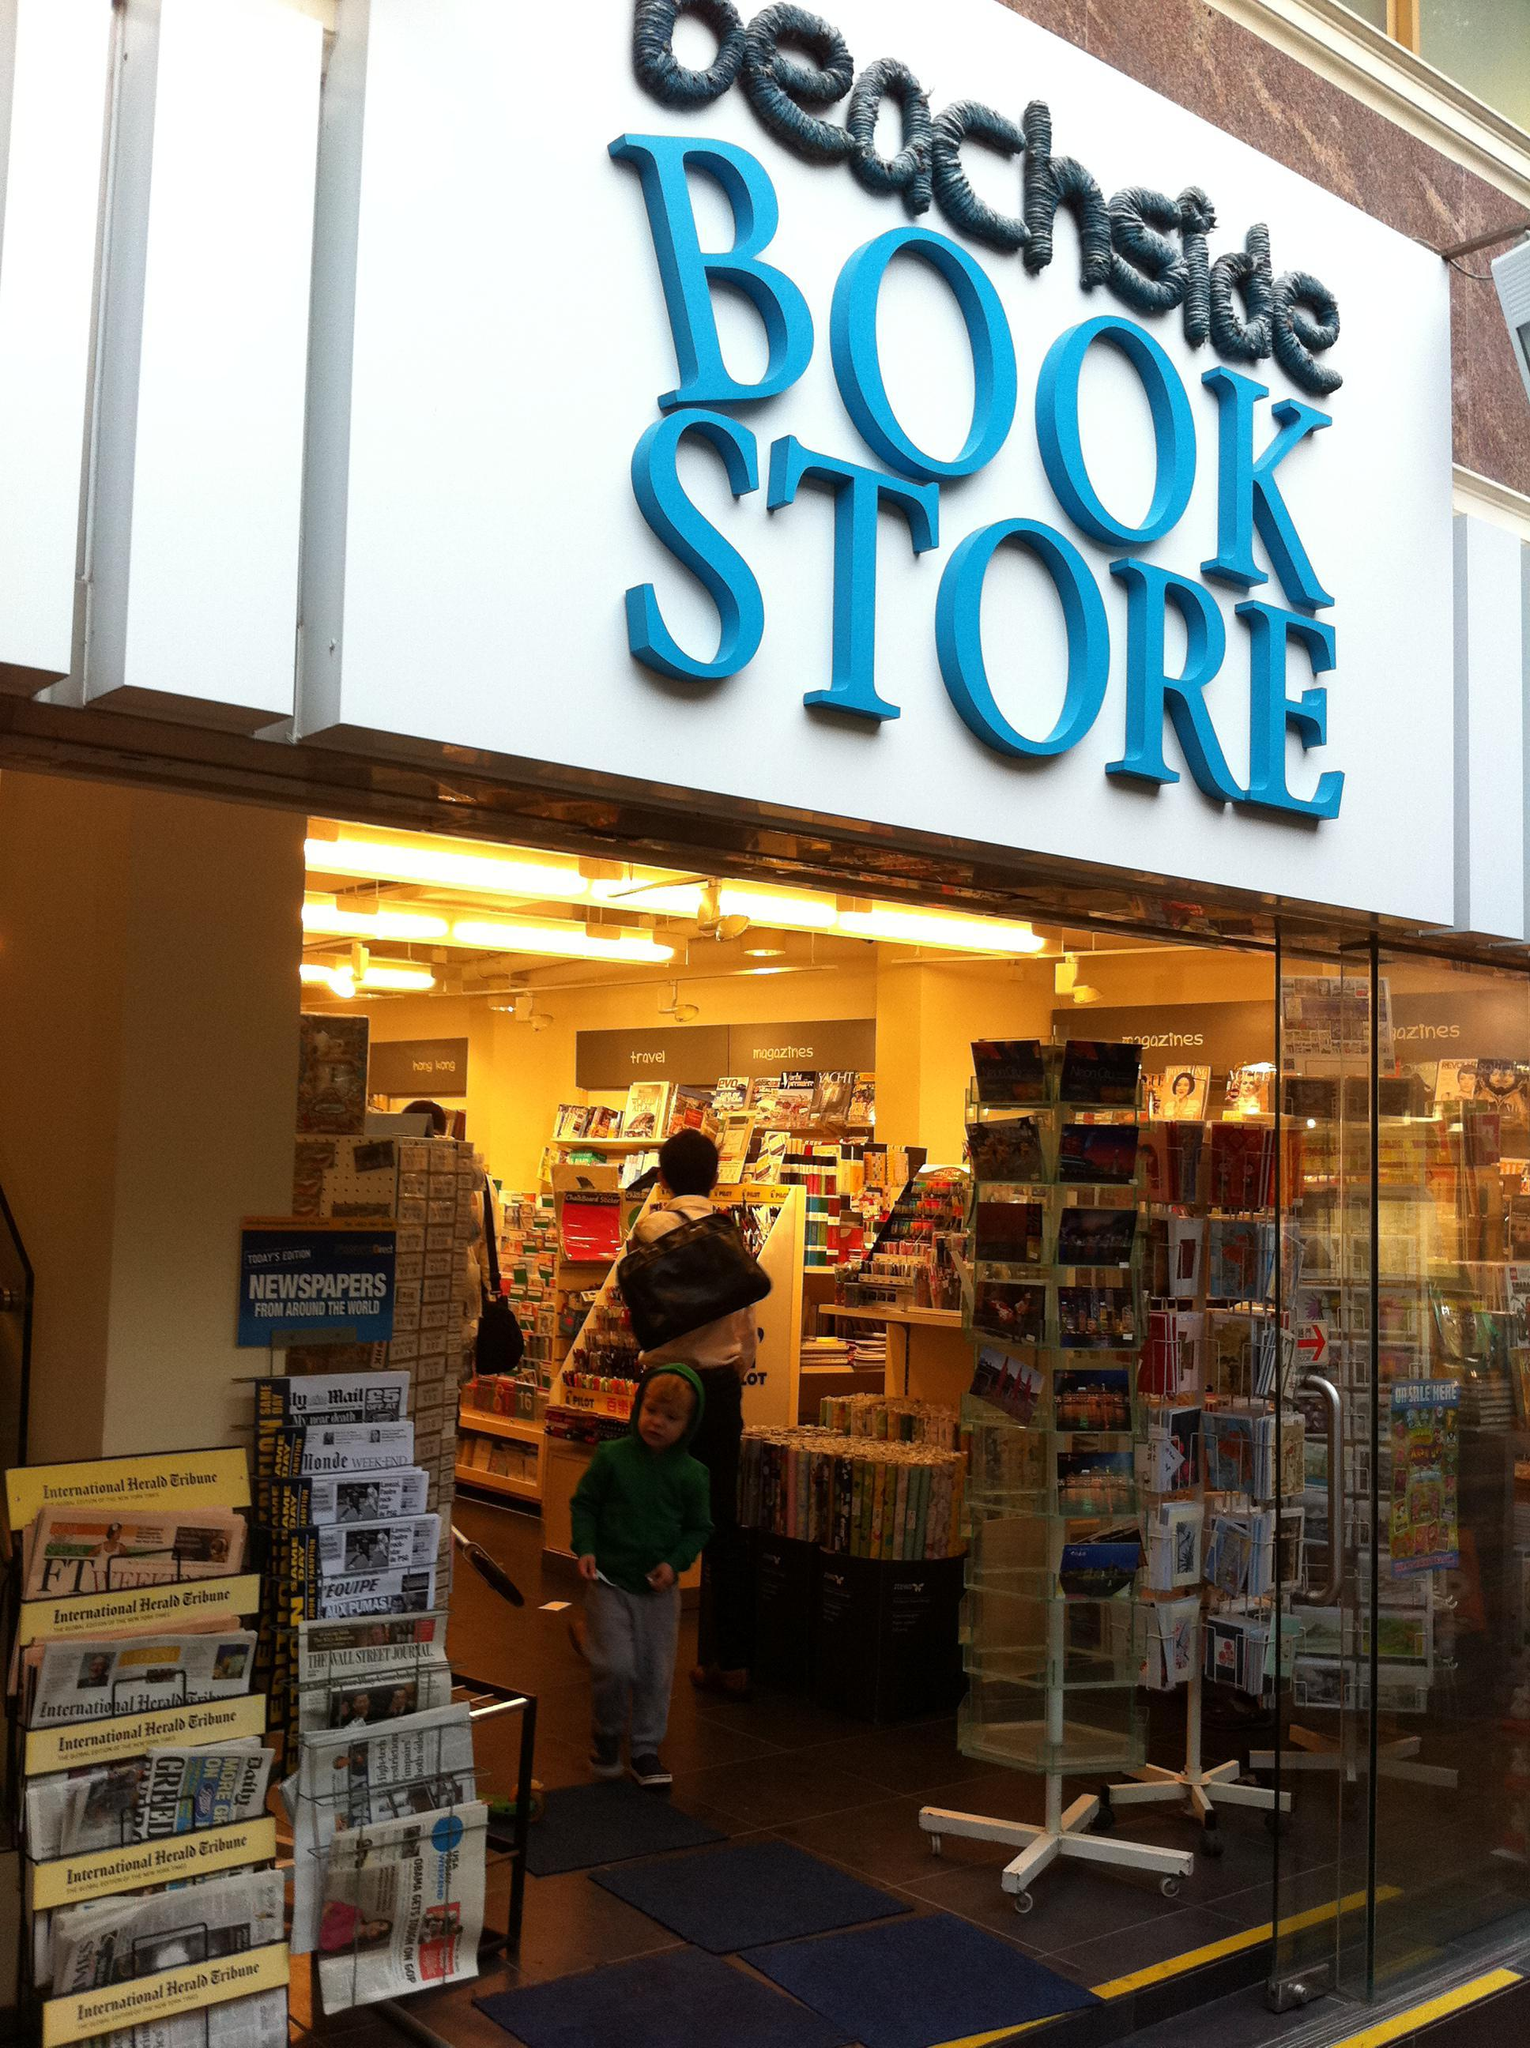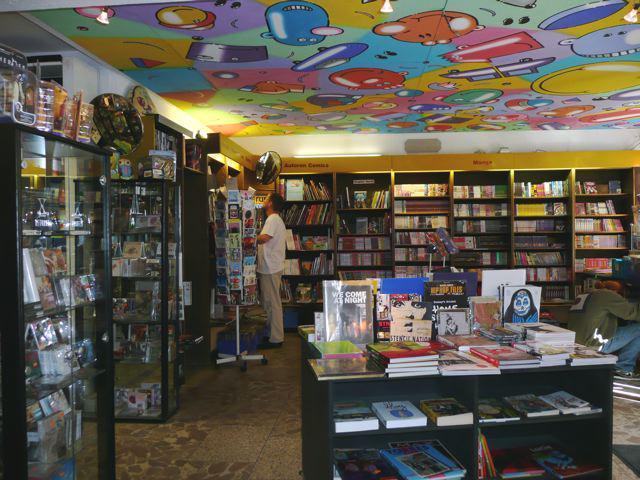The first image is the image on the left, the second image is the image on the right. Evaluate the accuracy of this statement regarding the images: "Both images show merchandise displayed inside an exterior window.". Is it true? Answer yes or no. No. The first image is the image on the left, the second image is the image on the right. Considering the images on both sides, is "Outside storefront views of local bookstores." valid? Answer yes or no. No. 